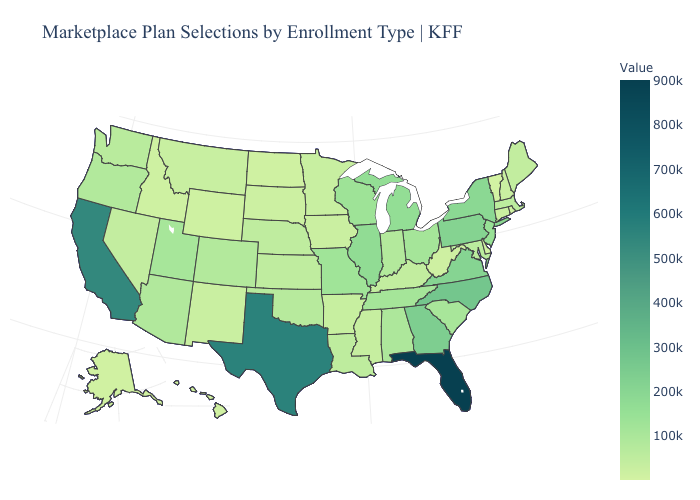Which states have the highest value in the USA?
Write a very short answer. Florida. Does New Jersey have the lowest value in the Northeast?
Write a very short answer. No. Among the states that border Pennsylvania , does New York have the highest value?
Keep it brief. Yes. Among the states that border Utah , which have the lowest value?
Short answer required. Idaho. Does Kansas have a higher value than Texas?
Short answer required. No. Among the states that border Texas , does New Mexico have the lowest value?
Write a very short answer. Yes. Does North Dakota have the lowest value in the MidWest?
Quick response, please. Yes. Which states hav the highest value in the Northeast?
Short answer required. Pennsylvania. 